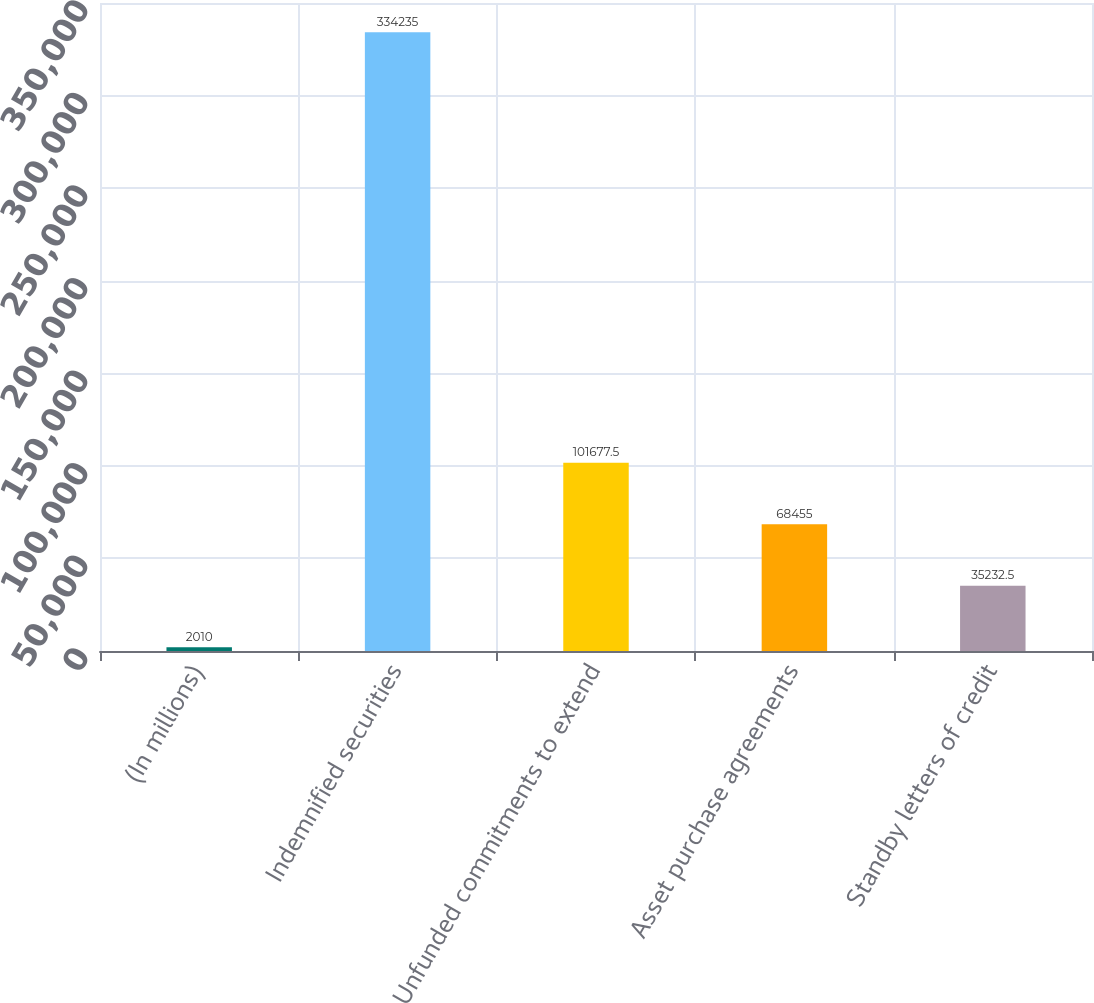Convert chart. <chart><loc_0><loc_0><loc_500><loc_500><bar_chart><fcel>(In millions)<fcel>Indemnified securities<fcel>Unfunded commitments to extend<fcel>Asset purchase agreements<fcel>Standby letters of credit<nl><fcel>2010<fcel>334235<fcel>101678<fcel>68455<fcel>35232.5<nl></chart> 